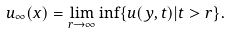<formula> <loc_0><loc_0><loc_500><loc_500>u _ { \infty } ( x ) = \lim _ { r \to \infty } \inf \{ u ( y , t ) | t > r \} .</formula> 